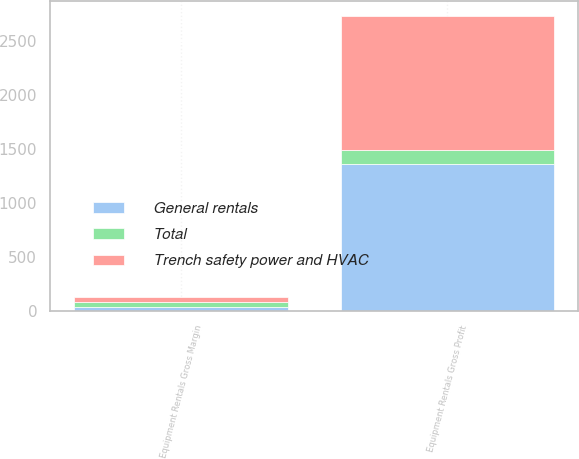Convert chart to OTSL. <chart><loc_0><loc_0><loc_500><loc_500><stacked_bar_chart><ecel><fcel>Equipment Rentals Gross Profit<fcel>Equipment Rentals Gross Margin<nl><fcel>Trench safety power and HVAC<fcel>1239<fcel>38.9<nl><fcel>Total<fcel>125<fcel>46.8<nl><fcel>General rentals<fcel>1364<fcel>39.5<nl></chart> 